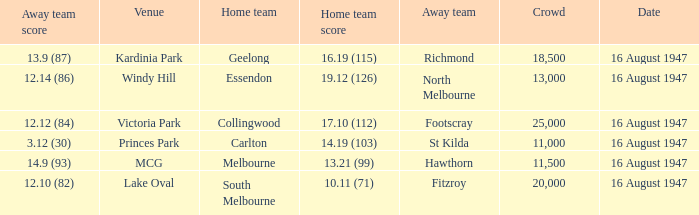What home team has had a crowd bigger than 20,000? Collingwood. 